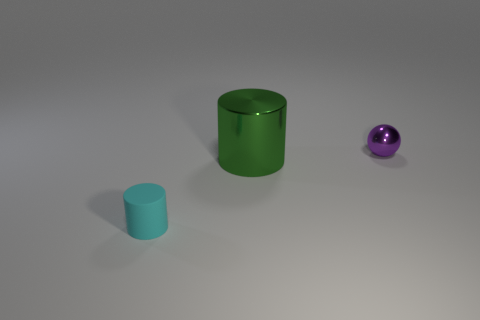Subtract 1 spheres. How many spheres are left? 0 Subtract 0 yellow cylinders. How many objects are left? 3 Subtract all cylinders. How many objects are left? 1 Subtract all red cylinders. Subtract all purple balls. How many cylinders are left? 2 Subtract all blue balls. How many green cylinders are left? 1 Subtract all small balls. Subtract all small matte cylinders. How many objects are left? 1 Add 2 small purple balls. How many small purple balls are left? 3 Add 3 large green metal objects. How many large green metal objects exist? 4 Add 1 purple balls. How many objects exist? 4 